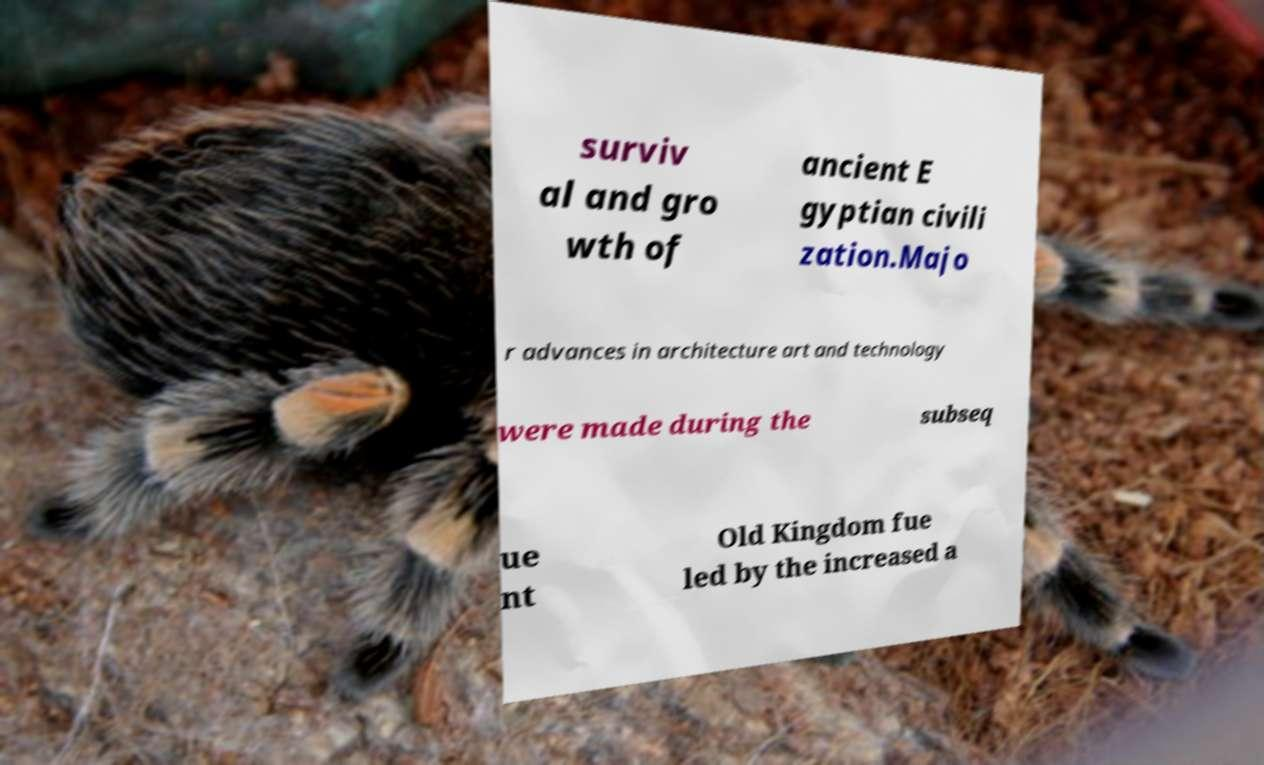Could you extract and type out the text from this image? surviv al and gro wth of ancient E gyptian civili zation.Majo r advances in architecture art and technology were made during the subseq ue nt Old Kingdom fue led by the increased a 